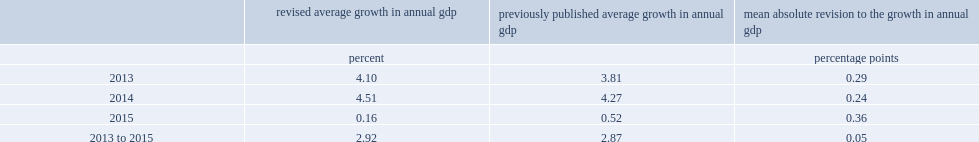For the period 2013 to 2015, what was the mean absolute percentage point revision to the annual growth rate in nominal gdp? 0.05. 